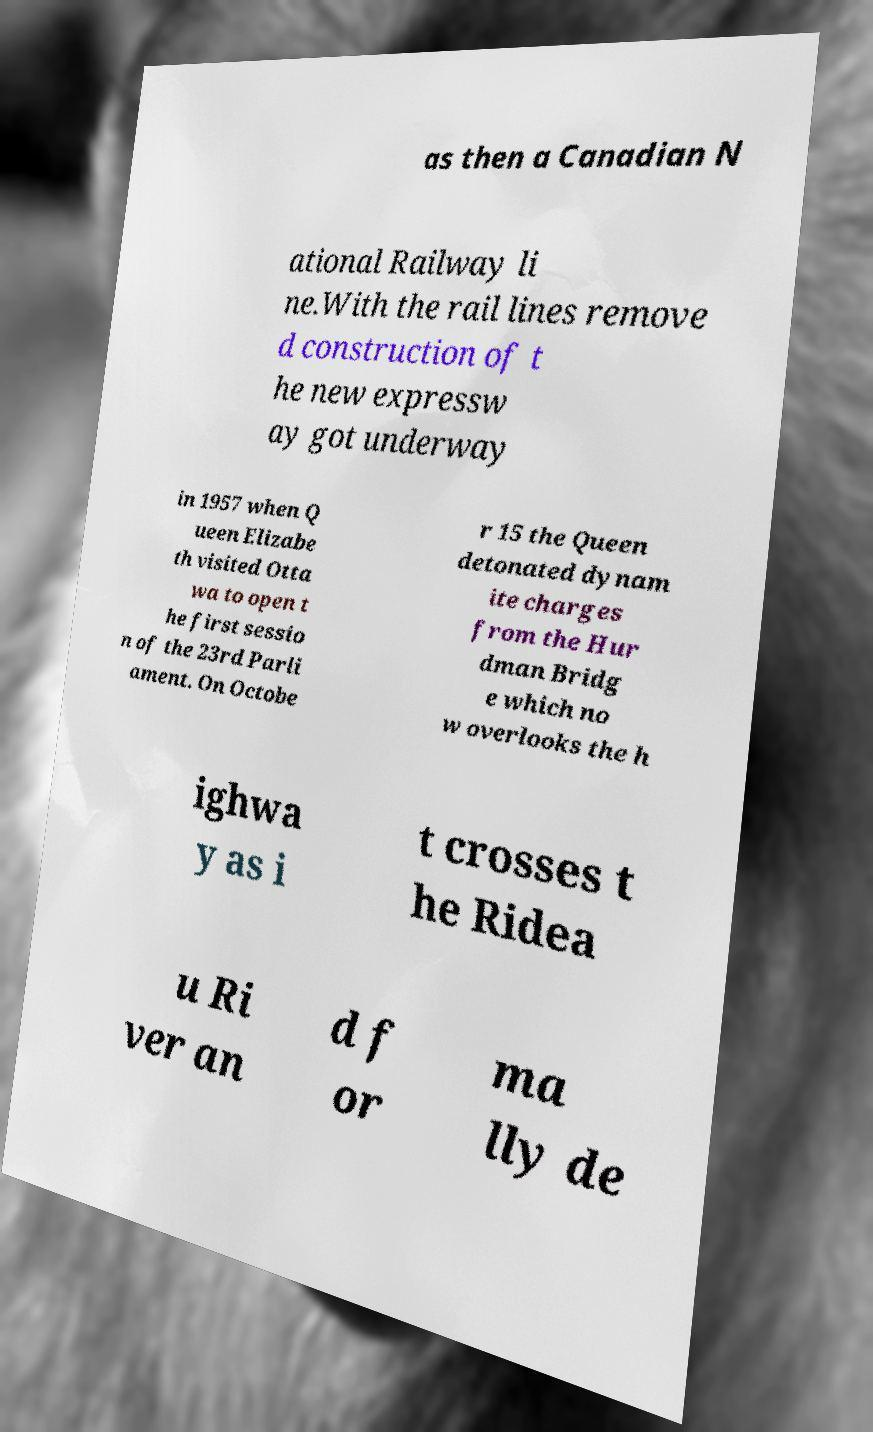Can you read and provide the text displayed in the image?This photo seems to have some interesting text. Can you extract and type it out for me? as then a Canadian N ational Railway li ne.With the rail lines remove d construction of t he new expressw ay got underway in 1957 when Q ueen Elizabe th visited Otta wa to open t he first sessio n of the 23rd Parli ament. On Octobe r 15 the Queen detonated dynam ite charges from the Hur dman Bridg e which no w overlooks the h ighwa y as i t crosses t he Ridea u Ri ver an d f or ma lly de 